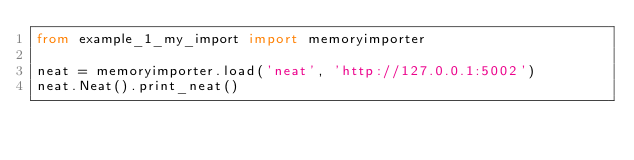<code> <loc_0><loc_0><loc_500><loc_500><_Python_>from example_1_my_import import memoryimporter

neat = memoryimporter.load('neat', 'http://127.0.0.1:5002')
neat.Neat().print_neat()
</code> 